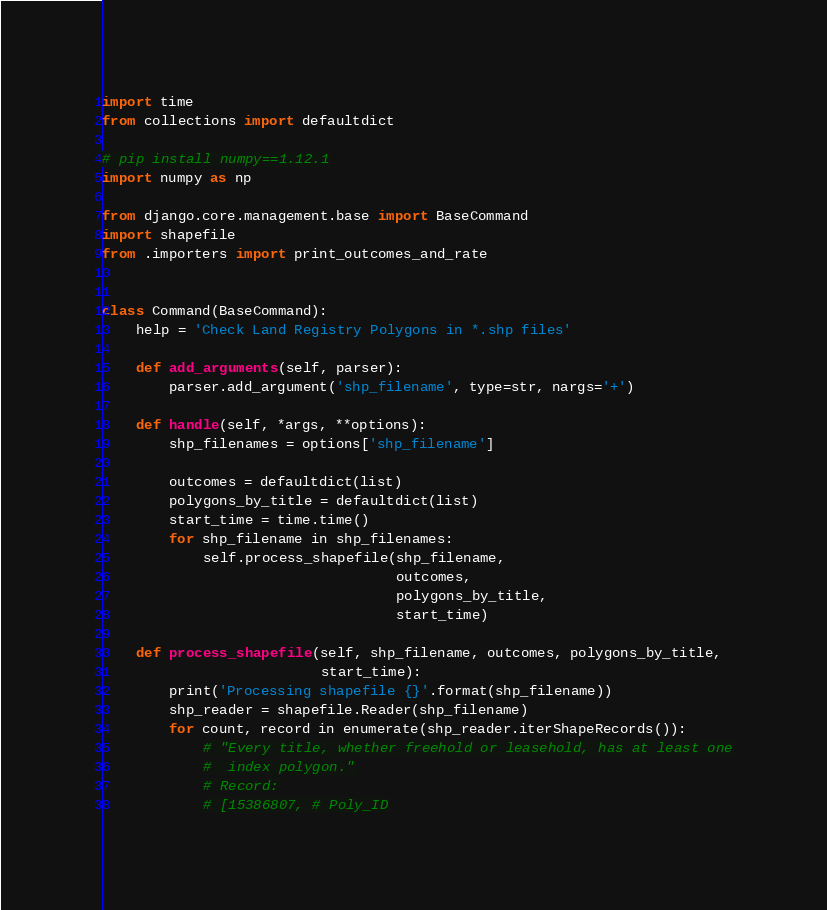<code> <loc_0><loc_0><loc_500><loc_500><_Python_>import time
from collections import defaultdict

# pip install numpy==1.12.1
import numpy as np

from django.core.management.base import BaseCommand
import shapefile
from .importers import print_outcomes_and_rate


class Command(BaseCommand):
    help = 'Check Land Registry Polygons in *.shp files'

    def add_arguments(self, parser):
        parser.add_argument('shp_filename', type=str, nargs='+')

    def handle(self, *args, **options):
        shp_filenames = options['shp_filename']

        outcomes = defaultdict(list)
        polygons_by_title = defaultdict(list)
        start_time = time.time()
        for shp_filename in shp_filenames:
            self.process_shapefile(shp_filename,
                                   outcomes,
                                   polygons_by_title,
                                   start_time)

    def process_shapefile(self, shp_filename, outcomes, polygons_by_title,
                          start_time):
        print('Processing shapefile {}'.format(shp_filename))
        shp_reader = shapefile.Reader(shp_filename)
        for count, record in enumerate(shp_reader.iterShapeRecords()):
            # "Every title, whether freehold or leasehold, has at least one
            #  index polygon."
            # Record:
            # [15386807, # Poly_ID</code> 